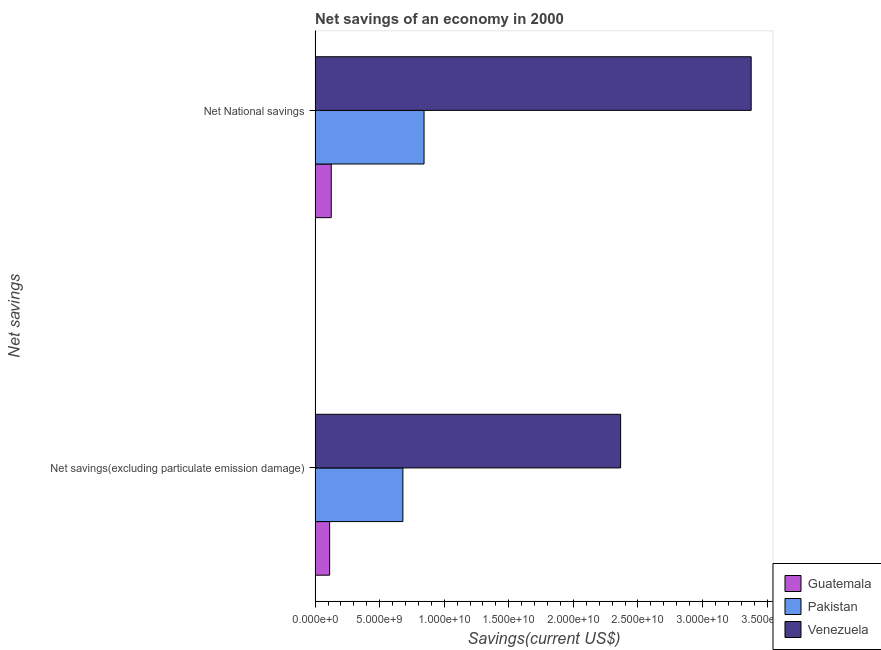How many different coloured bars are there?
Ensure brevity in your answer.  3. How many groups of bars are there?
Keep it short and to the point. 2. Are the number of bars on each tick of the Y-axis equal?
Provide a short and direct response. Yes. How many bars are there on the 1st tick from the top?
Offer a very short reply. 3. How many bars are there on the 2nd tick from the bottom?
Offer a terse response. 3. What is the label of the 2nd group of bars from the top?
Your answer should be compact. Net savings(excluding particulate emission damage). What is the net national savings in Venezuela?
Your response must be concise. 3.38e+1. Across all countries, what is the maximum net national savings?
Keep it short and to the point. 3.38e+1. Across all countries, what is the minimum net national savings?
Provide a succinct answer. 1.25e+09. In which country was the net savings(excluding particulate emission damage) maximum?
Keep it short and to the point. Venezuela. In which country was the net national savings minimum?
Give a very brief answer. Guatemala. What is the total net savings(excluding particulate emission damage) in the graph?
Make the answer very short. 3.16e+1. What is the difference between the net national savings in Venezuela and that in Guatemala?
Your answer should be very brief. 3.25e+1. What is the difference between the net national savings in Guatemala and the net savings(excluding particulate emission damage) in Venezuela?
Ensure brevity in your answer.  -2.24e+1. What is the average net savings(excluding particulate emission damage) per country?
Your answer should be compact. 1.05e+1. What is the difference between the net savings(excluding particulate emission damage) and net national savings in Venezuela?
Offer a very short reply. -1.01e+1. In how many countries, is the net savings(excluding particulate emission damage) greater than 34000000000 US$?
Ensure brevity in your answer.  0. What is the ratio of the net savings(excluding particulate emission damage) in Pakistan to that in Guatemala?
Your answer should be very brief. 6.04. What does the 2nd bar from the top in Net savings(excluding particulate emission damage) represents?
Keep it short and to the point. Pakistan. What does the 2nd bar from the bottom in Net savings(excluding particulate emission damage) represents?
Provide a short and direct response. Pakistan. How many bars are there?
Your answer should be very brief. 6. Are all the bars in the graph horizontal?
Ensure brevity in your answer.  Yes. What is the difference between two consecutive major ticks on the X-axis?
Provide a succinct answer. 5.00e+09. Does the graph contain grids?
Make the answer very short. No. What is the title of the graph?
Your answer should be very brief. Net savings of an economy in 2000. What is the label or title of the X-axis?
Ensure brevity in your answer.  Savings(current US$). What is the label or title of the Y-axis?
Your answer should be compact. Net savings. What is the Savings(current US$) in Guatemala in Net savings(excluding particulate emission damage)?
Your answer should be compact. 1.13e+09. What is the Savings(current US$) of Pakistan in Net savings(excluding particulate emission damage)?
Provide a succinct answer. 6.80e+09. What is the Savings(current US$) of Venezuela in Net savings(excluding particulate emission damage)?
Offer a very short reply. 2.37e+1. What is the Savings(current US$) in Guatemala in Net National savings?
Offer a terse response. 1.25e+09. What is the Savings(current US$) of Pakistan in Net National savings?
Provide a short and direct response. 8.44e+09. What is the Savings(current US$) in Venezuela in Net National savings?
Your response must be concise. 3.38e+1. Across all Net savings, what is the maximum Savings(current US$) of Guatemala?
Ensure brevity in your answer.  1.25e+09. Across all Net savings, what is the maximum Savings(current US$) of Pakistan?
Provide a short and direct response. 8.44e+09. Across all Net savings, what is the maximum Savings(current US$) in Venezuela?
Provide a succinct answer. 3.38e+1. Across all Net savings, what is the minimum Savings(current US$) in Guatemala?
Keep it short and to the point. 1.13e+09. Across all Net savings, what is the minimum Savings(current US$) of Pakistan?
Your response must be concise. 6.80e+09. Across all Net savings, what is the minimum Savings(current US$) of Venezuela?
Offer a terse response. 2.37e+1. What is the total Savings(current US$) in Guatemala in the graph?
Give a very brief answer. 2.38e+09. What is the total Savings(current US$) of Pakistan in the graph?
Make the answer very short. 1.52e+1. What is the total Savings(current US$) of Venezuela in the graph?
Your response must be concise. 5.74e+1. What is the difference between the Savings(current US$) in Guatemala in Net savings(excluding particulate emission damage) and that in Net National savings?
Provide a short and direct response. -1.25e+08. What is the difference between the Savings(current US$) of Pakistan in Net savings(excluding particulate emission damage) and that in Net National savings?
Your response must be concise. -1.64e+09. What is the difference between the Savings(current US$) in Venezuela in Net savings(excluding particulate emission damage) and that in Net National savings?
Provide a short and direct response. -1.01e+1. What is the difference between the Savings(current US$) of Guatemala in Net savings(excluding particulate emission damage) and the Savings(current US$) of Pakistan in Net National savings?
Ensure brevity in your answer.  -7.31e+09. What is the difference between the Savings(current US$) in Guatemala in Net savings(excluding particulate emission damage) and the Savings(current US$) in Venezuela in Net National savings?
Offer a very short reply. -3.26e+1. What is the difference between the Savings(current US$) of Pakistan in Net savings(excluding particulate emission damage) and the Savings(current US$) of Venezuela in Net National savings?
Offer a very short reply. -2.70e+1. What is the average Savings(current US$) of Guatemala per Net savings?
Offer a very short reply. 1.19e+09. What is the average Savings(current US$) of Pakistan per Net savings?
Ensure brevity in your answer.  7.62e+09. What is the average Savings(current US$) in Venezuela per Net savings?
Offer a very short reply. 2.87e+1. What is the difference between the Savings(current US$) in Guatemala and Savings(current US$) in Pakistan in Net savings(excluding particulate emission damage)?
Make the answer very short. -5.67e+09. What is the difference between the Savings(current US$) in Guatemala and Savings(current US$) in Venezuela in Net savings(excluding particulate emission damage)?
Ensure brevity in your answer.  -2.25e+1. What is the difference between the Savings(current US$) of Pakistan and Savings(current US$) of Venezuela in Net savings(excluding particulate emission damage)?
Offer a very short reply. -1.69e+1. What is the difference between the Savings(current US$) of Guatemala and Savings(current US$) of Pakistan in Net National savings?
Give a very brief answer. -7.19e+09. What is the difference between the Savings(current US$) of Guatemala and Savings(current US$) of Venezuela in Net National savings?
Give a very brief answer. -3.25e+1. What is the difference between the Savings(current US$) in Pakistan and Savings(current US$) in Venezuela in Net National savings?
Keep it short and to the point. -2.53e+1. What is the ratio of the Savings(current US$) of Guatemala in Net savings(excluding particulate emission damage) to that in Net National savings?
Your response must be concise. 0.9. What is the ratio of the Savings(current US$) of Pakistan in Net savings(excluding particulate emission damage) to that in Net National savings?
Give a very brief answer. 0.81. What is the ratio of the Savings(current US$) in Venezuela in Net savings(excluding particulate emission damage) to that in Net National savings?
Your answer should be compact. 0.7. What is the difference between the highest and the second highest Savings(current US$) of Guatemala?
Your answer should be compact. 1.25e+08. What is the difference between the highest and the second highest Savings(current US$) in Pakistan?
Make the answer very short. 1.64e+09. What is the difference between the highest and the second highest Savings(current US$) of Venezuela?
Your answer should be very brief. 1.01e+1. What is the difference between the highest and the lowest Savings(current US$) of Guatemala?
Your answer should be compact. 1.25e+08. What is the difference between the highest and the lowest Savings(current US$) of Pakistan?
Provide a succinct answer. 1.64e+09. What is the difference between the highest and the lowest Savings(current US$) of Venezuela?
Your answer should be very brief. 1.01e+1. 